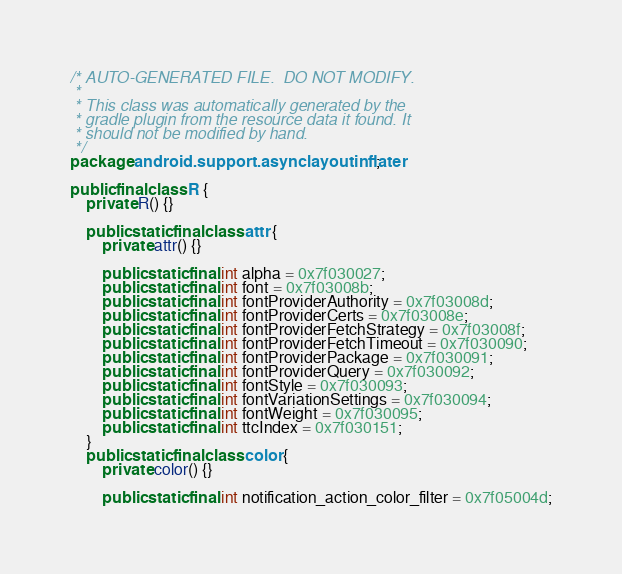<code> <loc_0><loc_0><loc_500><loc_500><_Java_>/* AUTO-GENERATED FILE.  DO NOT MODIFY.
 *
 * This class was automatically generated by the
 * gradle plugin from the resource data it found. It
 * should not be modified by hand.
 */
package android.support.asynclayoutinflater;

public final class R {
    private R() {}

    public static final class attr {
        private attr() {}

        public static final int alpha = 0x7f030027;
        public static final int font = 0x7f03008b;
        public static final int fontProviderAuthority = 0x7f03008d;
        public static final int fontProviderCerts = 0x7f03008e;
        public static final int fontProviderFetchStrategy = 0x7f03008f;
        public static final int fontProviderFetchTimeout = 0x7f030090;
        public static final int fontProviderPackage = 0x7f030091;
        public static final int fontProviderQuery = 0x7f030092;
        public static final int fontStyle = 0x7f030093;
        public static final int fontVariationSettings = 0x7f030094;
        public static final int fontWeight = 0x7f030095;
        public static final int ttcIndex = 0x7f030151;
    }
    public static final class color {
        private color() {}

        public static final int notification_action_color_filter = 0x7f05004d;</code> 